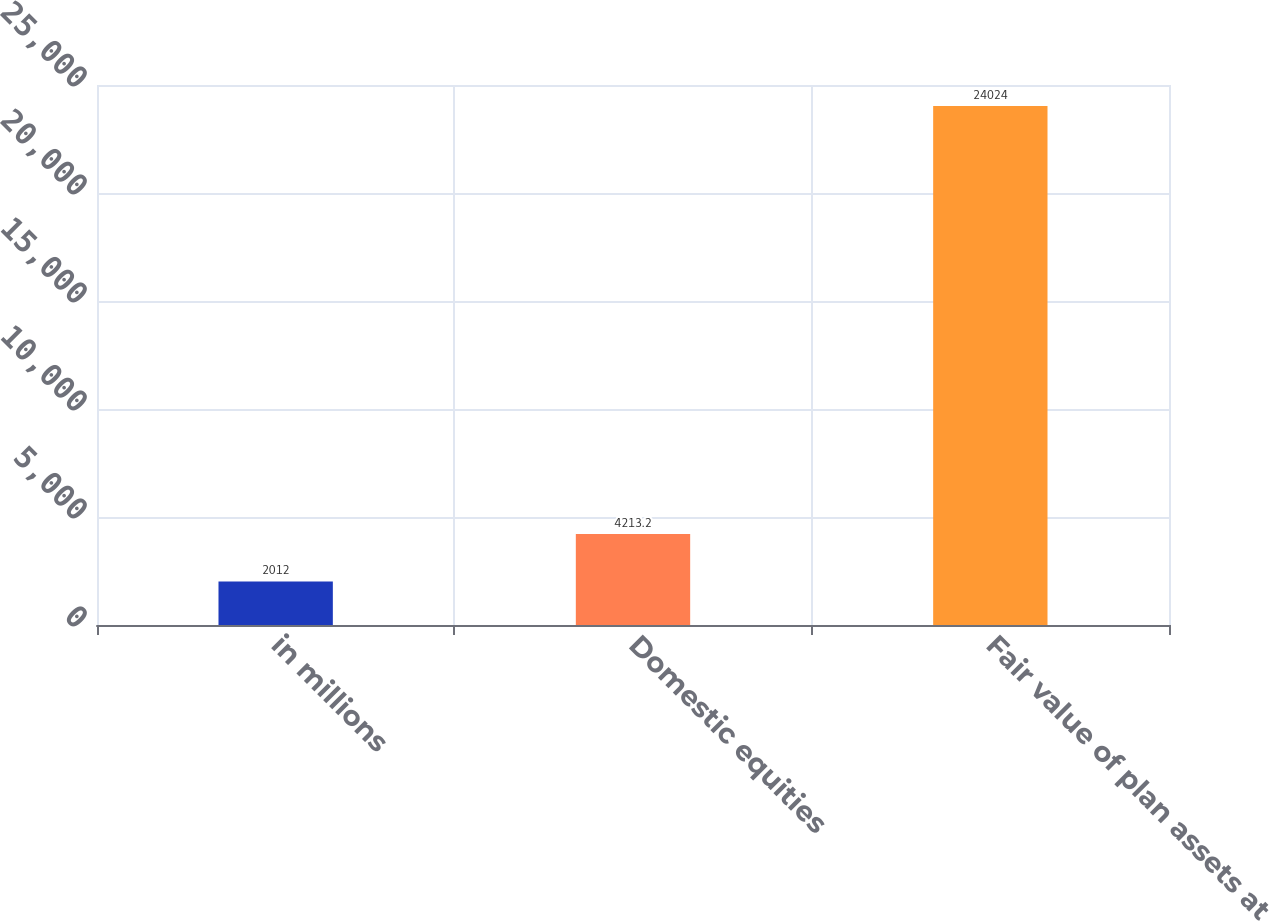Convert chart. <chart><loc_0><loc_0><loc_500><loc_500><bar_chart><fcel>in millions<fcel>Domestic equities<fcel>Fair value of plan assets at<nl><fcel>2012<fcel>4213.2<fcel>24024<nl></chart> 